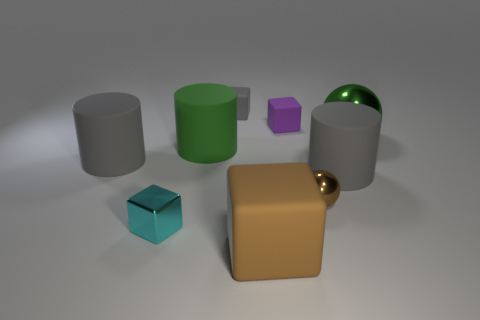What number of objects are cyan objects or brown metallic things?
Your response must be concise. 2. What is the size of the matte object that is both in front of the purple object and right of the big brown rubber object?
Your response must be concise. Large. Is the number of big green things behind the large brown cube less than the number of large brown things?
Your answer should be compact. No. There is a green object that is made of the same material as the gray block; what is its shape?
Make the answer very short. Cylinder. There is a shiny thing in front of the small brown ball; does it have the same shape as the small rubber thing that is to the right of the big rubber block?
Provide a succinct answer. Yes. Are there fewer small matte objects behind the gray block than tiny purple rubber cubes that are to the left of the small purple cube?
Make the answer very short. No. What is the shape of the large rubber object that is the same color as the large shiny sphere?
Give a very brief answer. Cylinder. What number of brown things have the same size as the green rubber object?
Make the answer very short. 1. Does the tiny block behind the small purple rubber block have the same material as the big sphere?
Offer a very short reply. No. Are any yellow matte spheres visible?
Offer a terse response. No. 